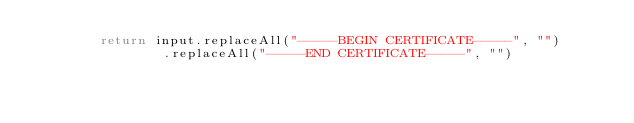Convert code to text. <code><loc_0><loc_0><loc_500><loc_500><_Java_>        return input.replaceAll("-----BEGIN CERTIFICATE-----", "")
                .replaceAll("-----END CERTIFICATE-----", "")</code> 